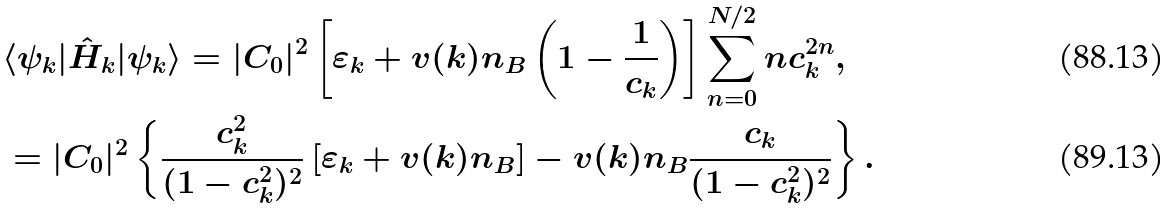Convert formula to latex. <formula><loc_0><loc_0><loc_500><loc_500>& \langle \psi _ { k } | \hat { H } _ { k } | \psi _ { k } \rangle = | C _ { 0 } | ^ { 2 } \left [ \varepsilon _ { k } + v ( k ) n _ { B } \left ( 1 - \frac { 1 } { c _ { k } } \right ) \right ] \sum _ { n = 0 } ^ { N / 2 } n c _ { k } ^ { 2 n } , \\ & = | C _ { 0 } | ^ { 2 } \left \{ \frac { c _ { k } ^ { 2 } } { ( 1 - c _ { k } ^ { 2 } ) ^ { 2 } } \left [ \varepsilon _ { k } + v ( k ) n _ { B } \right ] - v ( k ) n _ { B } \frac { c _ { k } } { ( 1 - c _ { k } ^ { 2 } ) ^ { 2 } } \right \} .</formula> 